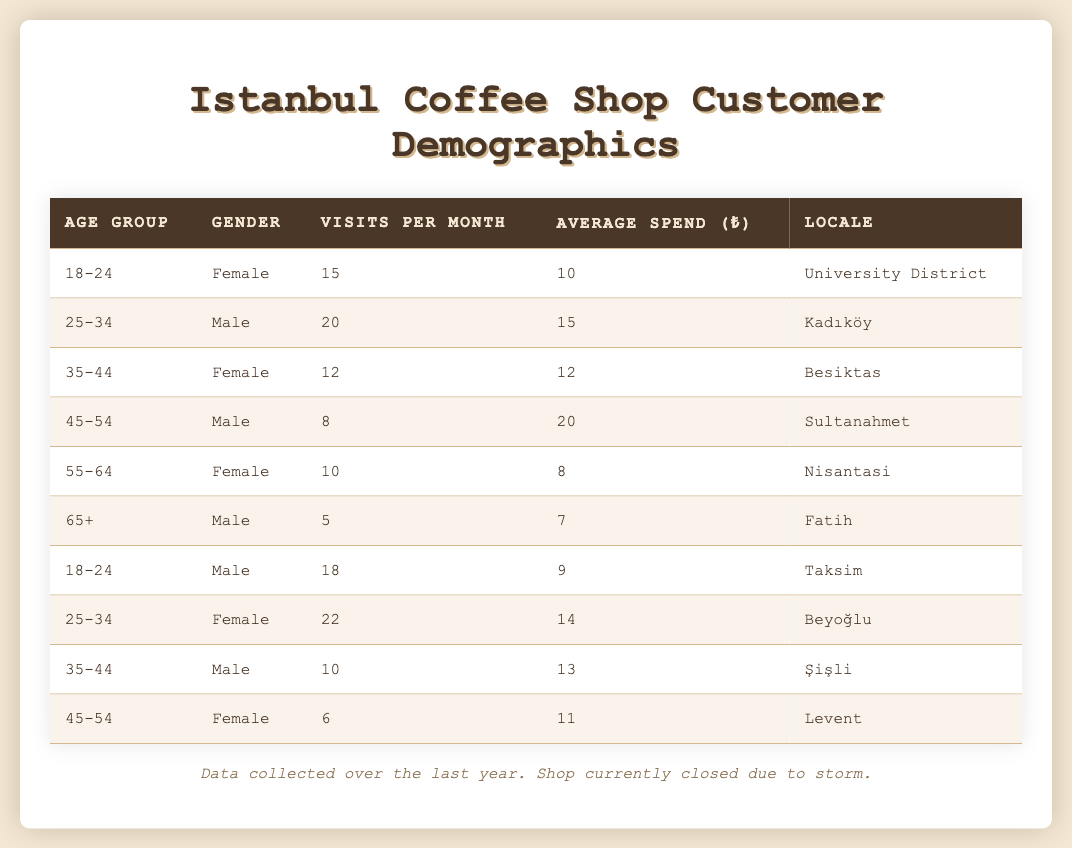What is the average spend per visit for customers aged 25-34? The two groups aged 25-34 have spends of 15 and 14. To find the average, we add these (15 + 14) = 29 and divide by the number of groups (2), so 29/2 = 14.5.
Answer: 14.5 Which age group has the highest visits per month? The age group 25-34 (Male) has the highest visits per month at 20, as shown in the table.
Answer: 25-34 Is it true that the average spend for customers aged 45-54 is higher for males than for females? The males aged 45-54 have an average spend of 20, while the females have an average spend of 11. Since 20 is greater than 11, the statement is true.
Answer: True What is the total number of visits from the 18-24 age group? The total visits for the 18-24 age group can be calculated by adding the visits of both genders: Female (15) + Male (18) = 33 visits.
Answer: 33 Which locale has the most frequent visitors based on visits per month? Adding the visits per month for each demographic shows that Beyoğlu at 22 visits and Kadıköy at 20 visits are the highest, Beyoğlu has the most frequent visitors with 22 visits.
Answer: Beyoğlu How does the average spend of female customers compare to male customers aged 35-44? The females aged 35-44 spend an average of 12, while the males in this group spend an average of 13. Therefore, males spend more on average.
Answer: Males spend more What is the median number of visits per month across all age groups? Listing the visits per month in order: 5, 6, 8, 10, 10, 12, 15, 15, 18, 20, 22 (11 data points). The median is the middle value, which is 12 (the 6th value).
Answer: 12 If the storm affected only male customers, how many total visits would be lost? The total visits for males are: 20 (Kadıköy) + 8 (Sultanahmet) + 5 (Fatih) + 18 (Taksim) + 10 (Şişli) = 61 visits.
Answer: 61 Which gender has a higher average spend across all age groups? To calculate the total for each gender: Females (10 + 12 + 8 + 14 + 11 = 55) with 5 groups gives an average of 11. Male spending totals to (15 + 20 + 7 + 9 + 13 = 64) with 5 groups gives an average of 12.8. Males have a higher average spend.
Answer: Males What age group has the lowest average spend per person? The average spend for the 65+ age group is 7, the lowest when comparing to other age groups listed.
Answer: 65+ Which age group has the least number of visits per month? The age group 65+ (Male) has the least visits with 5 per month noted in the table.
Answer: 65+ 